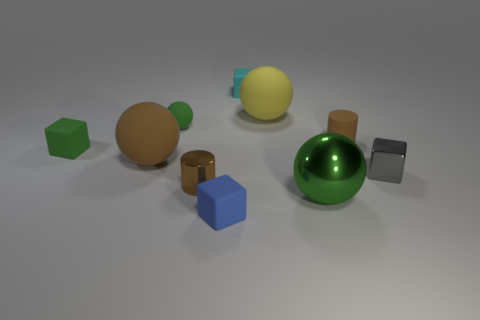Subtract all purple blocks. How many green balls are left? 2 Subtract 1 blocks. How many blocks are left? 3 Subtract all yellow spheres. How many spheres are left? 3 Subtract all matte blocks. How many blocks are left? 1 Subtract all cylinders. How many objects are left? 8 Subtract all purple spheres. Subtract all purple cylinders. How many spheres are left? 4 Add 1 matte objects. How many matte objects are left? 8 Add 2 purple metallic objects. How many purple metallic objects exist? 2 Subtract 1 cyan blocks. How many objects are left? 9 Subtract all large cyan matte cubes. Subtract all blue blocks. How many objects are left? 9 